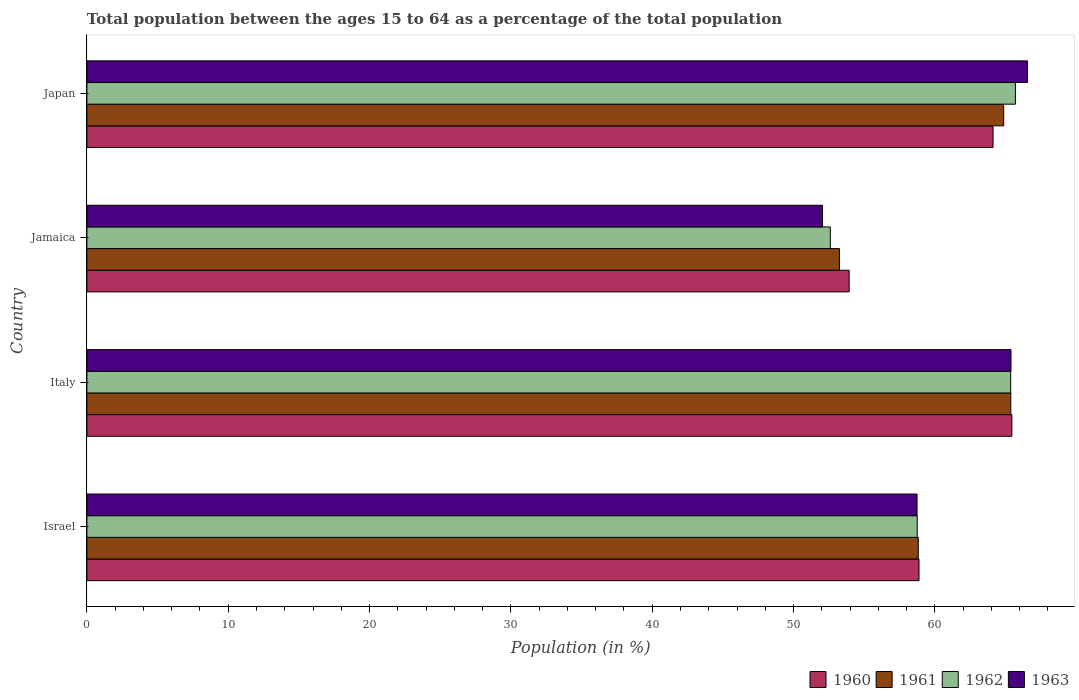How many different coloured bars are there?
Keep it short and to the point. 4. Are the number of bars per tick equal to the number of legend labels?
Offer a very short reply. Yes. Are the number of bars on each tick of the Y-axis equal?
Your answer should be compact. Yes. What is the label of the 3rd group of bars from the top?
Your answer should be very brief. Italy. In how many cases, is the number of bars for a given country not equal to the number of legend labels?
Your response must be concise. 0. What is the percentage of the population ages 15 to 64 in 1962 in Jamaica?
Your answer should be very brief. 52.6. Across all countries, what is the maximum percentage of the population ages 15 to 64 in 1960?
Your response must be concise. 65.45. Across all countries, what is the minimum percentage of the population ages 15 to 64 in 1963?
Ensure brevity in your answer.  52.05. In which country was the percentage of the population ages 15 to 64 in 1963 maximum?
Ensure brevity in your answer.  Japan. In which country was the percentage of the population ages 15 to 64 in 1961 minimum?
Make the answer very short. Jamaica. What is the total percentage of the population ages 15 to 64 in 1962 in the graph?
Make the answer very short. 242.41. What is the difference between the percentage of the population ages 15 to 64 in 1960 in Israel and that in Jamaica?
Keep it short and to the point. 4.94. What is the difference between the percentage of the population ages 15 to 64 in 1962 in Japan and the percentage of the population ages 15 to 64 in 1960 in Israel?
Your response must be concise. 6.82. What is the average percentage of the population ages 15 to 64 in 1962 per country?
Your answer should be compact. 60.6. What is the difference between the percentage of the population ages 15 to 64 in 1961 and percentage of the population ages 15 to 64 in 1963 in Japan?
Make the answer very short. -1.68. In how many countries, is the percentage of the population ages 15 to 64 in 1961 greater than 28 ?
Provide a short and direct response. 4. What is the ratio of the percentage of the population ages 15 to 64 in 1961 in Israel to that in Japan?
Make the answer very short. 0.91. Is the percentage of the population ages 15 to 64 in 1963 in Italy less than that in Japan?
Provide a short and direct response. Yes. Is the difference between the percentage of the population ages 15 to 64 in 1961 in Israel and Japan greater than the difference between the percentage of the population ages 15 to 64 in 1963 in Israel and Japan?
Provide a succinct answer. Yes. What is the difference between the highest and the second highest percentage of the population ages 15 to 64 in 1963?
Give a very brief answer. 1.17. What is the difference between the highest and the lowest percentage of the population ages 15 to 64 in 1963?
Your response must be concise. 14.5. Is the sum of the percentage of the population ages 15 to 64 in 1963 in Italy and Japan greater than the maximum percentage of the population ages 15 to 64 in 1961 across all countries?
Your answer should be very brief. Yes. Is it the case that in every country, the sum of the percentage of the population ages 15 to 64 in 1962 and percentage of the population ages 15 to 64 in 1961 is greater than the percentage of the population ages 15 to 64 in 1963?
Offer a very short reply. Yes. How many bars are there?
Your response must be concise. 16. Are the values on the major ticks of X-axis written in scientific E-notation?
Your answer should be very brief. No. Does the graph contain any zero values?
Your response must be concise. No. Does the graph contain grids?
Offer a terse response. No. Where does the legend appear in the graph?
Provide a succinct answer. Bottom right. How many legend labels are there?
Keep it short and to the point. 4. What is the title of the graph?
Give a very brief answer. Total population between the ages 15 to 64 as a percentage of the total population. Does "2001" appear as one of the legend labels in the graph?
Provide a succinct answer. No. What is the label or title of the X-axis?
Give a very brief answer. Population (in %). What is the label or title of the Y-axis?
Provide a succinct answer. Country. What is the Population (in %) of 1960 in Israel?
Offer a terse response. 58.88. What is the Population (in %) in 1961 in Israel?
Your answer should be very brief. 58.82. What is the Population (in %) of 1962 in Israel?
Make the answer very short. 58.75. What is the Population (in %) in 1963 in Israel?
Keep it short and to the point. 58.74. What is the Population (in %) of 1960 in Italy?
Provide a succinct answer. 65.45. What is the Population (in %) in 1961 in Italy?
Provide a succinct answer. 65.37. What is the Population (in %) in 1962 in Italy?
Provide a succinct answer. 65.36. What is the Population (in %) in 1963 in Italy?
Give a very brief answer. 65.38. What is the Population (in %) of 1960 in Jamaica?
Make the answer very short. 53.93. What is the Population (in %) of 1961 in Jamaica?
Your answer should be compact. 53.25. What is the Population (in %) of 1962 in Jamaica?
Offer a very short reply. 52.6. What is the Population (in %) in 1963 in Jamaica?
Give a very brief answer. 52.05. What is the Population (in %) in 1960 in Japan?
Your response must be concise. 64.11. What is the Population (in %) of 1961 in Japan?
Offer a very short reply. 64.87. What is the Population (in %) of 1962 in Japan?
Provide a short and direct response. 65.7. What is the Population (in %) in 1963 in Japan?
Keep it short and to the point. 66.55. Across all countries, what is the maximum Population (in %) in 1960?
Make the answer very short. 65.45. Across all countries, what is the maximum Population (in %) of 1961?
Your answer should be compact. 65.37. Across all countries, what is the maximum Population (in %) in 1962?
Keep it short and to the point. 65.7. Across all countries, what is the maximum Population (in %) in 1963?
Provide a succinct answer. 66.55. Across all countries, what is the minimum Population (in %) of 1960?
Provide a short and direct response. 53.93. Across all countries, what is the minimum Population (in %) of 1961?
Provide a succinct answer. 53.25. Across all countries, what is the minimum Population (in %) of 1962?
Give a very brief answer. 52.6. Across all countries, what is the minimum Population (in %) in 1963?
Keep it short and to the point. 52.05. What is the total Population (in %) of 1960 in the graph?
Offer a very short reply. 242.37. What is the total Population (in %) of 1961 in the graph?
Your response must be concise. 242.31. What is the total Population (in %) of 1962 in the graph?
Offer a terse response. 242.41. What is the total Population (in %) in 1963 in the graph?
Provide a short and direct response. 242.72. What is the difference between the Population (in %) in 1960 in Israel and that in Italy?
Provide a succinct answer. -6.57. What is the difference between the Population (in %) in 1961 in Israel and that in Italy?
Keep it short and to the point. -6.55. What is the difference between the Population (in %) in 1962 in Israel and that in Italy?
Your answer should be very brief. -6.61. What is the difference between the Population (in %) of 1963 in Israel and that in Italy?
Your answer should be compact. -6.65. What is the difference between the Population (in %) of 1960 in Israel and that in Jamaica?
Offer a very short reply. 4.94. What is the difference between the Population (in %) in 1961 in Israel and that in Jamaica?
Give a very brief answer. 5.58. What is the difference between the Population (in %) in 1962 in Israel and that in Jamaica?
Your response must be concise. 6.15. What is the difference between the Population (in %) in 1963 in Israel and that in Jamaica?
Your answer should be compact. 6.69. What is the difference between the Population (in %) of 1960 in Israel and that in Japan?
Your answer should be very brief. -5.24. What is the difference between the Population (in %) in 1961 in Israel and that in Japan?
Keep it short and to the point. -6.04. What is the difference between the Population (in %) of 1962 in Israel and that in Japan?
Offer a terse response. -6.95. What is the difference between the Population (in %) in 1963 in Israel and that in Japan?
Your answer should be compact. -7.81. What is the difference between the Population (in %) of 1960 in Italy and that in Jamaica?
Provide a succinct answer. 11.51. What is the difference between the Population (in %) of 1961 in Italy and that in Jamaica?
Keep it short and to the point. 12.13. What is the difference between the Population (in %) of 1962 in Italy and that in Jamaica?
Keep it short and to the point. 12.76. What is the difference between the Population (in %) of 1963 in Italy and that in Jamaica?
Give a very brief answer. 13.34. What is the difference between the Population (in %) in 1960 in Italy and that in Japan?
Your answer should be compact. 1.33. What is the difference between the Population (in %) in 1961 in Italy and that in Japan?
Your response must be concise. 0.5. What is the difference between the Population (in %) in 1962 in Italy and that in Japan?
Offer a terse response. -0.33. What is the difference between the Population (in %) in 1963 in Italy and that in Japan?
Offer a terse response. -1.17. What is the difference between the Population (in %) of 1960 in Jamaica and that in Japan?
Keep it short and to the point. -10.18. What is the difference between the Population (in %) in 1961 in Jamaica and that in Japan?
Ensure brevity in your answer.  -11.62. What is the difference between the Population (in %) in 1962 in Jamaica and that in Japan?
Provide a succinct answer. -13.1. What is the difference between the Population (in %) in 1963 in Jamaica and that in Japan?
Your answer should be very brief. -14.5. What is the difference between the Population (in %) in 1960 in Israel and the Population (in %) in 1961 in Italy?
Offer a very short reply. -6.5. What is the difference between the Population (in %) in 1960 in Israel and the Population (in %) in 1962 in Italy?
Your response must be concise. -6.49. What is the difference between the Population (in %) in 1960 in Israel and the Population (in %) in 1963 in Italy?
Make the answer very short. -6.51. What is the difference between the Population (in %) of 1961 in Israel and the Population (in %) of 1962 in Italy?
Keep it short and to the point. -6.54. What is the difference between the Population (in %) in 1961 in Israel and the Population (in %) in 1963 in Italy?
Your response must be concise. -6.56. What is the difference between the Population (in %) in 1962 in Israel and the Population (in %) in 1963 in Italy?
Make the answer very short. -6.63. What is the difference between the Population (in %) of 1960 in Israel and the Population (in %) of 1961 in Jamaica?
Provide a succinct answer. 5.63. What is the difference between the Population (in %) in 1960 in Israel and the Population (in %) in 1962 in Jamaica?
Make the answer very short. 6.28. What is the difference between the Population (in %) of 1960 in Israel and the Population (in %) of 1963 in Jamaica?
Provide a short and direct response. 6.83. What is the difference between the Population (in %) of 1961 in Israel and the Population (in %) of 1962 in Jamaica?
Your answer should be compact. 6.22. What is the difference between the Population (in %) of 1961 in Israel and the Population (in %) of 1963 in Jamaica?
Your answer should be very brief. 6.78. What is the difference between the Population (in %) of 1962 in Israel and the Population (in %) of 1963 in Jamaica?
Provide a short and direct response. 6.7. What is the difference between the Population (in %) in 1960 in Israel and the Population (in %) in 1961 in Japan?
Give a very brief answer. -5.99. What is the difference between the Population (in %) in 1960 in Israel and the Population (in %) in 1962 in Japan?
Ensure brevity in your answer.  -6.82. What is the difference between the Population (in %) of 1960 in Israel and the Population (in %) of 1963 in Japan?
Make the answer very short. -7.67. What is the difference between the Population (in %) in 1961 in Israel and the Population (in %) in 1962 in Japan?
Your response must be concise. -6.87. What is the difference between the Population (in %) in 1961 in Israel and the Population (in %) in 1963 in Japan?
Your response must be concise. -7.73. What is the difference between the Population (in %) in 1962 in Israel and the Population (in %) in 1963 in Japan?
Your response must be concise. -7.8. What is the difference between the Population (in %) of 1960 in Italy and the Population (in %) of 1961 in Jamaica?
Your answer should be very brief. 12.2. What is the difference between the Population (in %) in 1960 in Italy and the Population (in %) in 1962 in Jamaica?
Offer a very short reply. 12.85. What is the difference between the Population (in %) in 1960 in Italy and the Population (in %) in 1963 in Jamaica?
Keep it short and to the point. 13.4. What is the difference between the Population (in %) in 1961 in Italy and the Population (in %) in 1962 in Jamaica?
Your answer should be compact. 12.77. What is the difference between the Population (in %) in 1961 in Italy and the Population (in %) in 1963 in Jamaica?
Make the answer very short. 13.32. What is the difference between the Population (in %) in 1962 in Italy and the Population (in %) in 1963 in Jamaica?
Give a very brief answer. 13.32. What is the difference between the Population (in %) in 1960 in Italy and the Population (in %) in 1961 in Japan?
Your answer should be very brief. 0.58. What is the difference between the Population (in %) of 1960 in Italy and the Population (in %) of 1962 in Japan?
Ensure brevity in your answer.  -0.25. What is the difference between the Population (in %) in 1960 in Italy and the Population (in %) in 1963 in Japan?
Ensure brevity in your answer.  -1.1. What is the difference between the Population (in %) in 1961 in Italy and the Population (in %) in 1962 in Japan?
Ensure brevity in your answer.  -0.33. What is the difference between the Population (in %) in 1961 in Italy and the Population (in %) in 1963 in Japan?
Provide a succinct answer. -1.18. What is the difference between the Population (in %) in 1962 in Italy and the Population (in %) in 1963 in Japan?
Offer a terse response. -1.19. What is the difference between the Population (in %) in 1960 in Jamaica and the Population (in %) in 1961 in Japan?
Keep it short and to the point. -10.93. What is the difference between the Population (in %) of 1960 in Jamaica and the Population (in %) of 1962 in Japan?
Provide a succinct answer. -11.76. What is the difference between the Population (in %) of 1960 in Jamaica and the Population (in %) of 1963 in Japan?
Your response must be concise. -12.62. What is the difference between the Population (in %) of 1961 in Jamaica and the Population (in %) of 1962 in Japan?
Offer a terse response. -12.45. What is the difference between the Population (in %) in 1961 in Jamaica and the Population (in %) in 1963 in Japan?
Give a very brief answer. -13.3. What is the difference between the Population (in %) of 1962 in Jamaica and the Population (in %) of 1963 in Japan?
Offer a very short reply. -13.95. What is the average Population (in %) of 1960 per country?
Ensure brevity in your answer.  60.59. What is the average Population (in %) in 1961 per country?
Offer a terse response. 60.58. What is the average Population (in %) in 1962 per country?
Your response must be concise. 60.6. What is the average Population (in %) in 1963 per country?
Make the answer very short. 60.68. What is the difference between the Population (in %) of 1960 and Population (in %) of 1961 in Israel?
Keep it short and to the point. 0.05. What is the difference between the Population (in %) of 1960 and Population (in %) of 1962 in Israel?
Ensure brevity in your answer.  0.13. What is the difference between the Population (in %) in 1960 and Population (in %) in 1963 in Israel?
Provide a succinct answer. 0.14. What is the difference between the Population (in %) in 1961 and Population (in %) in 1962 in Israel?
Your answer should be compact. 0.07. What is the difference between the Population (in %) in 1961 and Population (in %) in 1963 in Israel?
Offer a very short reply. 0.09. What is the difference between the Population (in %) of 1962 and Population (in %) of 1963 in Israel?
Give a very brief answer. 0.01. What is the difference between the Population (in %) in 1960 and Population (in %) in 1961 in Italy?
Offer a terse response. 0.08. What is the difference between the Population (in %) in 1960 and Population (in %) in 1962 in Italy?
Your answer should be compact. 0.08. What is the difference between the Population (in %) in 1960 and Population (in %) in 1963 in Italy?
Offer a terse response. 0.06. What is the difference between the Population (in %) in 1961 and Population (in %) in 1962 in Italy?
Your answer should be very brief. 0.01. What is the difference between the Population (in %) of 1961 and Population (in %) of 1963 in Italy?
Provide a succinct answer. -0.01. What is the difference between the Population (in %) of 1962 and Population (in %) of 1963 in Italy?
Make the answer very short. -0.02. What is the difference between the Population (in %) of 1960 and Population (in %) of 1961 in Jamaica?
Offer a very short reply. 0.69. What is the difference between the Population (in %) of 1960 and Population (in %) of 1962 in Jamaica?
Provide a short and direct response. 1.33. What is the difference between the Population (in %) of 1960 and Population (in %) of 1963 in Jamaica?
Your response must be concise. 1.89. What is the difference between the Population (in %) of 1961 and Population (in %) of 1962 in Jamaica?
Offer a very short reply. 0.65. What is the difference between the Population (in %) of 1961 and Population (in %) of 1963 in Jamaica?
Provide a succinct answer. 1.2. What is the difference between the Population (in %) in 1962 and Population (in %) in 1963 in Jamaica?
Offer a terse response. 0.55. What is the difference between the Population (in %) of 1960 and Population (in %) of 1961 in Japan?
Ensure brevity in your answer.  -0.75. What is the difference between the Population (in %) in 1960 and Population (in %) in 1962 in Japan?
Your answer should be compact. -1.58. What is the difference between the Population (in %) of 1960 and Population (in %) of 1963 in Japan?
Make the answer very short. -2.43. What is the difference between the Population (in %) of 1961 and Population (in %) of 1962 in Japan?
Your answer should be compact. -0.83. What is the difference between the Population (in %) in 1961 and Population (in %) in 1963 in Japan?
Make the answer very short. -1.68. What is the difference between the Population (in %) of 1962 and Population (in %) of 1963 in Japan?
Make the answer very short. -0.85. What is the ratio of the Population (in %) of 1960 in Israel to that in Italy?
Your response must be concise. 0.9. What is the ratio of the Population (in %) of 1961 in Israel to that in Italy?
Ensure brevity in your answer.  0.9. What is the ratio of the Population (in %) in 1962 in Israel to that in Italy?
Provide a succinct answer. 0.9. What is the ratio of the Population (in %) in 1963 in Israel to that in Italy?
Your answer should be very brief. 0.9. What is the ratio of the Population (in %) in 1960 in Israel to that in Jamaica?
Offer a terse response. 1.09. What is the ratio of the Population (in %) in 1961 in Israel to that in Jamaica?
Ensure brevity in your answer.  1.1. What is the ratio of the Population (in %) in 1962 in Israel to that in Jamaica?
Your answer should be compact. 1.12. What is the ratio of the Population (in %) of 1963 in Israel to that in Jamaica?
Provide a succinct answer. 1.13. What is the ratio of the Population (in %) of 1960 in Israel to that in Japan?
Provide a short and direct response. 0.92. What is the ratio of the Population (in %) of 1961 in Israel to that in Japan?
Your response must be concise. 0.91. What is the ratio of the Population (in %) of 1962 in Israel to that in Japan?
Your response must be concise. 0.89. What is the ratio of the Population (in %) in 1963 in Israel to that in Japan?
Offer a very short reply. 0.88. What is the ratio of the Population (in %) of 1960 in Italy to that in Jamaica?
Your answer should be very brief. 1.21. What is the ratio of the Population (in %) of 1961 in Italy to that in Jamaica?
Give a very brief answer. 1.23. What is the ratio of the Population (in %) in 1962 in Italy to that in Jamaica?
Provide a short and direct response. 1.24. What is the ratio of the Population (in %) of 1963 in Italy to that in Jamaica?
Offer a terse response. 1.26. What is the ratio of the Population (in %) in 1960 in Italy to that in Japan?
Your response must be concise. 1.02. What is the ratio of the Population (in %) of 1961 in Italy to that in Japan?
Offer a terse response. 1.01. What is the ratio of the Population (in %) in 1962 in Italy to that in Japan?
Offer a terse response. 0.99. What is the ratio of the Population (in %) of 1963 in Italy to that in Japan?
Your answer should be very brief. 0.98. What is the ratio of the Population (in %) in 1960 in Jamaica to that in Japan?
Provide a short and direct response. 0.84. What is the ratio of the Population (in %) in 1961 in Jamaica to that in Japan?
Offer a very short reply. 0.82. What is the ratio of the Population (in %) in 1962 in Jamaica to that in Japan?
Make the answer very short. 0.8. What is the ratio of the Population (in %) in 1963 in Jamaica to that in Japan?
Your answer should be very brief. 0.78. What is the difference between the highest and the second highest Population (in %) of 1960?
Provide a succinct answer. 1.33. What is the difference between the highest and the second highest Population (in %) in 1961?
Your answer should be very brief. 0.5. What is the difference between the highest and the second highest Population (in %) of 1962?
Ensure brevity in your answer.  0.33. What is the difference between the highest and the second highest Population (in %) in 1963?
Offer a terse response. 1.17. What is the difference between the highest and the lowest Population (in %) in 1960?
Your answer should be very brief. 11.51. What is the difference between the highest and the lowest Population (in %) of 1961?
Offer a terse response. 12.13. What is the difference between the highest and the lowest Population (in %) in 1962?
Provide a short and direct response. 13.1. What is the difference between the highest and the lowest Population (in %) of 1963?
Ensure brevity in your answer.  14.5. 